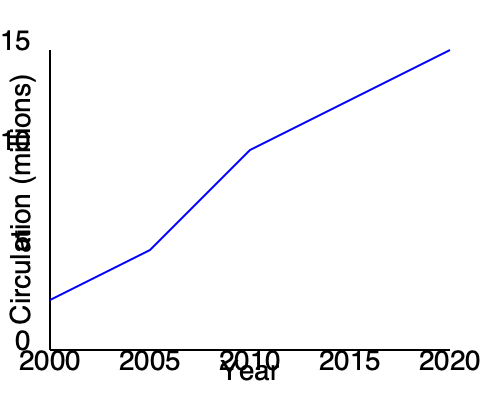As a senior editor who values collaboration, how would you interpret the trend in newspaper circulation from 2000 to 2020, and what strategies might you propose to address this trend? To interpret the trend and propose strategies, let's break down the analysis step-by-step:

1. Observe the overall trend:
   The line graph shows a clear downward trend in newspaper circulation from 2000 to 2020.

2. Quantify the decline:
   - In 2000, circulation was around 10 million.
   - By 2020, circulation dropped to approximately 5 million.
   - This represents a roughly 50% decrease over 20 years.

3. Note the rate of decline:
   The steepest decline appears to be between 2005 and 2015, suggesting an acceleration of the trend during this period.

4. Consider potential causes:
   - Rise of digital media and online news sources
   - Changing reader preferences
   - Competition from social media platforms

5. Propose strategies (considering the collaborative aspect of the editor's persona):
   a) Digital Integration: Collaborate with the digital team to develop a strong online presence and mobile apps.
   b) Content Diversification: Work with various departments to create unique, high-quality content that differentiates from free online sources.
   c) Community Engagement: Partner with local organizations to increase relevance and foster reader loyalty.
   d) Subscription Models: Collaborate with the business team to develop flexible subscription options that combine print and digital access.
   e) Data-Driven Decision Making: Work with analytics teams to understand reader preferences and tailor content accordingly.
   f) Cross-Platform Storytelling: Collaborate with multimedia teams to create engaging content across print, digital, and social media platforms.

6. Emphasize collaboration:
   Stress the importance of cross-departmental teamwork in implementing these strategies, aligning with the editor's belief in the power of collaborative idea generation.
Answer: Steep decline in circulation; propose collaborative strategies for digital integration, content diversification, and multi-platform engagement. 